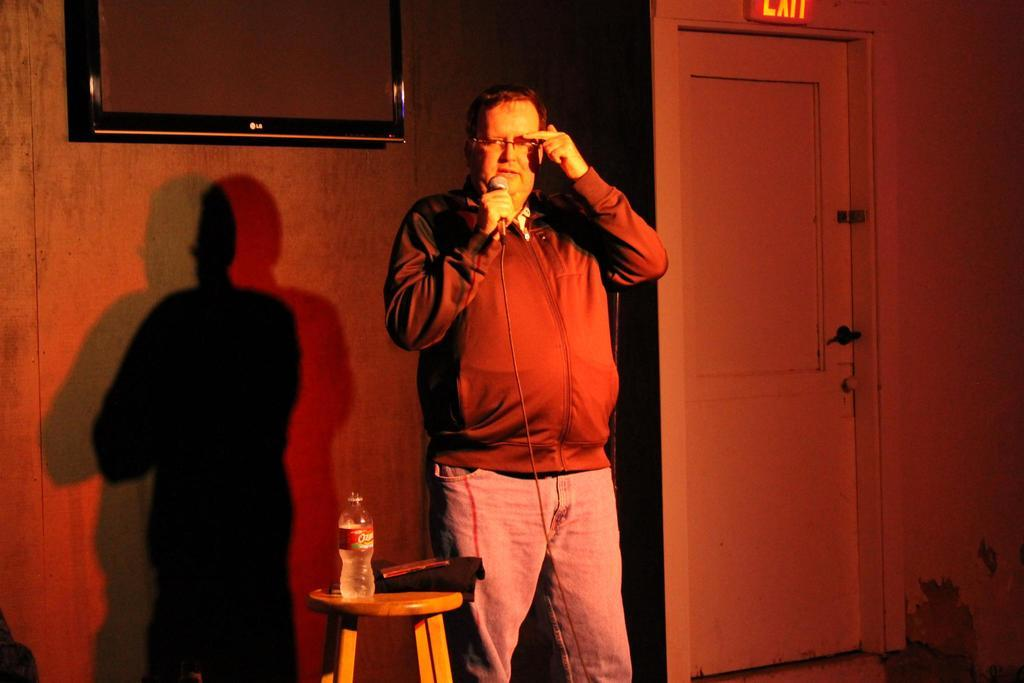What is the man holding in the image? The man is holding a mic and wire jacket. What can be seen on the table in the image? There is a bottle on the table. What is on the wall in the image? There is a television on the wall. What is the door in the image like? There is a door with a handle in the image. What is on top of the door in the image? There is an exit board on top of the door. What type of seed is being crushed in the image? There is no seed or crushing activity present in the image. 